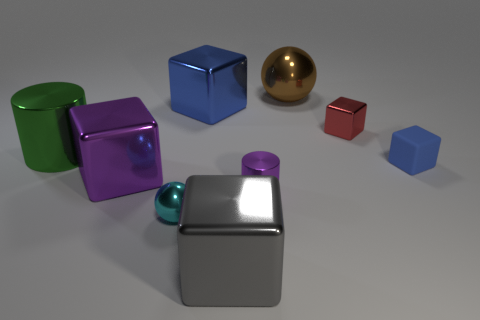There is a metal cylinder that is behind the small rubber cube in front of the green cylinder; what number of tiny metallic objects are in front of it?
Give a very brief answer. 2. There is a blue thing that is on the right side of the large brown thing; what is its shape?
Provide a succinct answer. Cube. What number of other things are there of the same material as the tiny red cube
Offer a very short reply. 7. Are there fewer shiny cubes in front of the tiny purple metallic object than large metallic cylinders that are to the right of the green thing?
Make the answer very short. No. What color is the other small matte object that is the same shape as the red object?
Give a very brief answer. Blue. There is a block to the right of the red metal object; is it the same size as the cyan metallic object?
Provide a short and direct response. Yes. Are there fewer tiny things on the left side of the red thing than large blue shiny objects?
Your answer should be very brief. No. There is a metal cylinder right of the metallic sphere that is in front of the small red metal object; what is its size?
Ensure brevity in your answer.  Small. Is the number of large yellow cylinders less than the number of big purple things?
Provide a short and direct response. Yes. What is the object that is to the right of the small metallic cylinder and in front of the large metal cylinder made of?
Ensure brevity in your answer.  Rubber. 